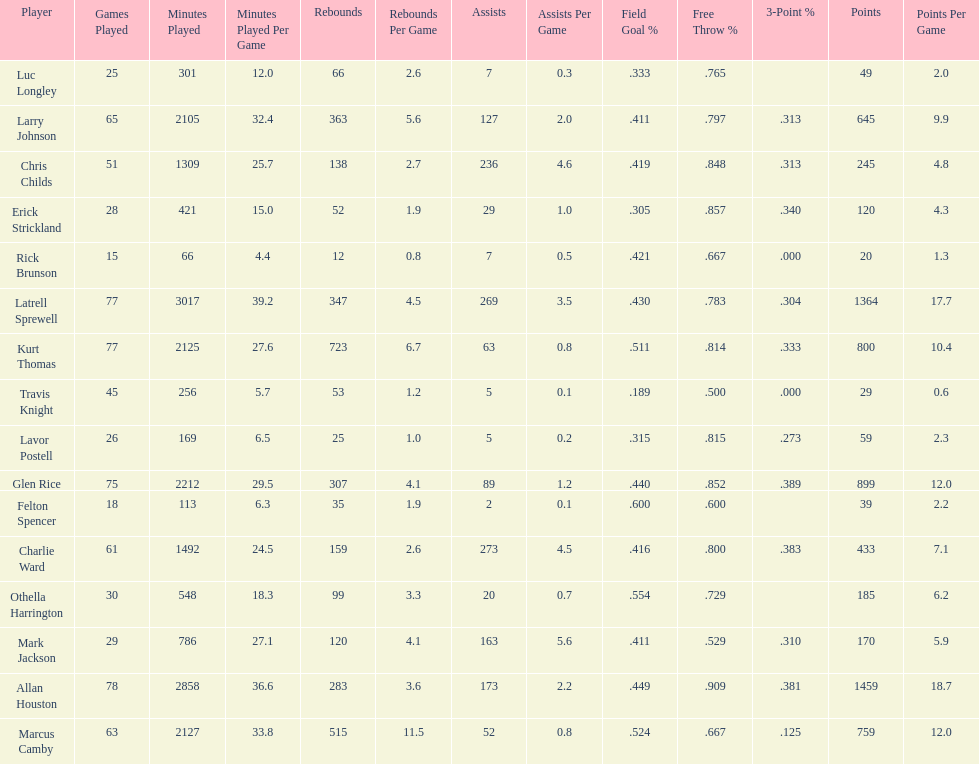Who scored more points, larry johnson or charlie ward? Larry Johnson. 